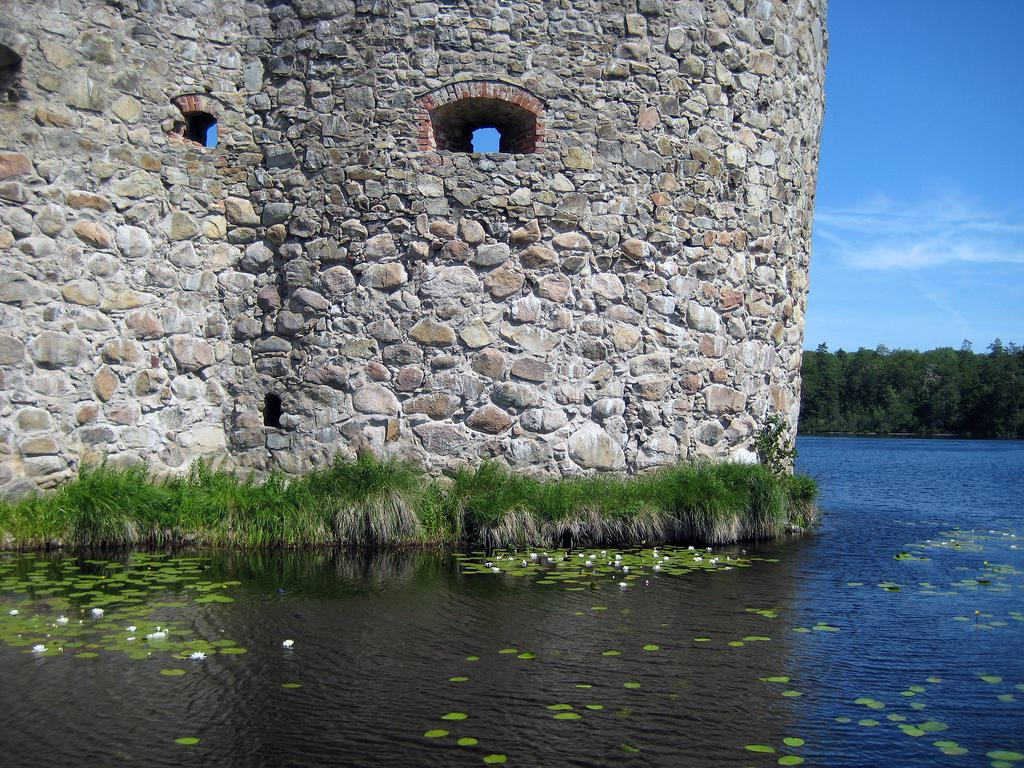What is the primary element visible in the image? There is water in the image. What else can be seen in the image besides the water? There are plants and a brick wall in front of the water. Are there any trees visible in the image? Yes, there are trees in the right corner of the image. What type of sound can be heard coming from the girl in the image? There is no girl present in the image, so it is not possible to determine what sound might be heard. 